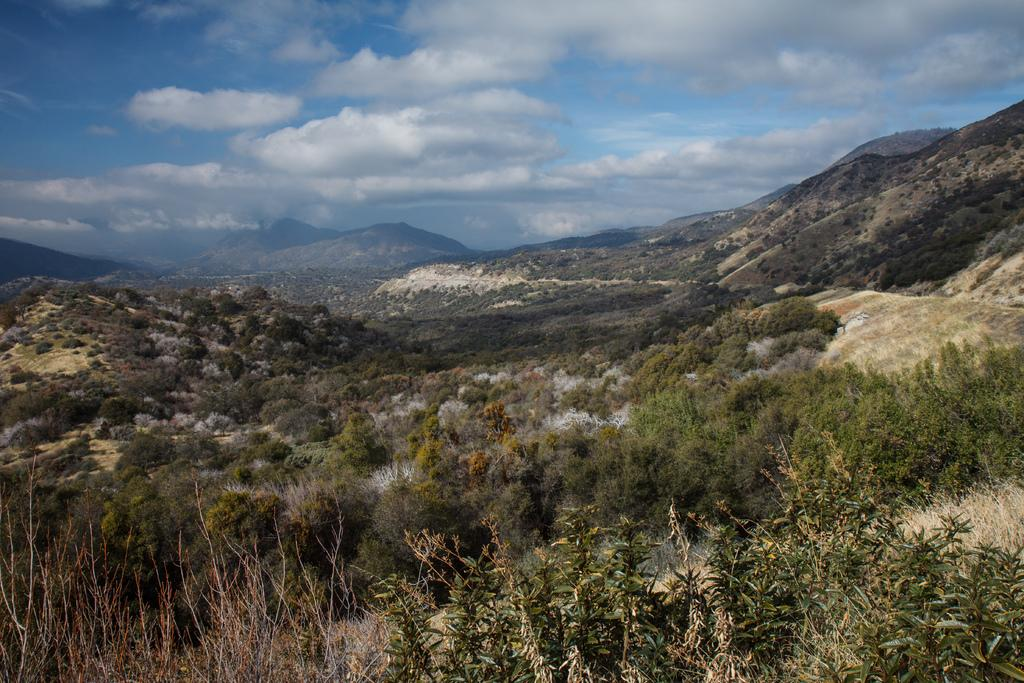What type of living organisms can be seen in the image? Plants can be seen in the image. How are the plants arranged in the image? The plants are arranged from left to right in the image. What can be seen in the background of the image? Mountains are visible in the background of the image. What is the color and condition of the sky in the image? The sky is blue and cloudy in the image. What is the opinion of the plants about the hobbies of the person taking the picture? Plants do not have opinions, and there is no indication in the image that a person is taking the picture. 